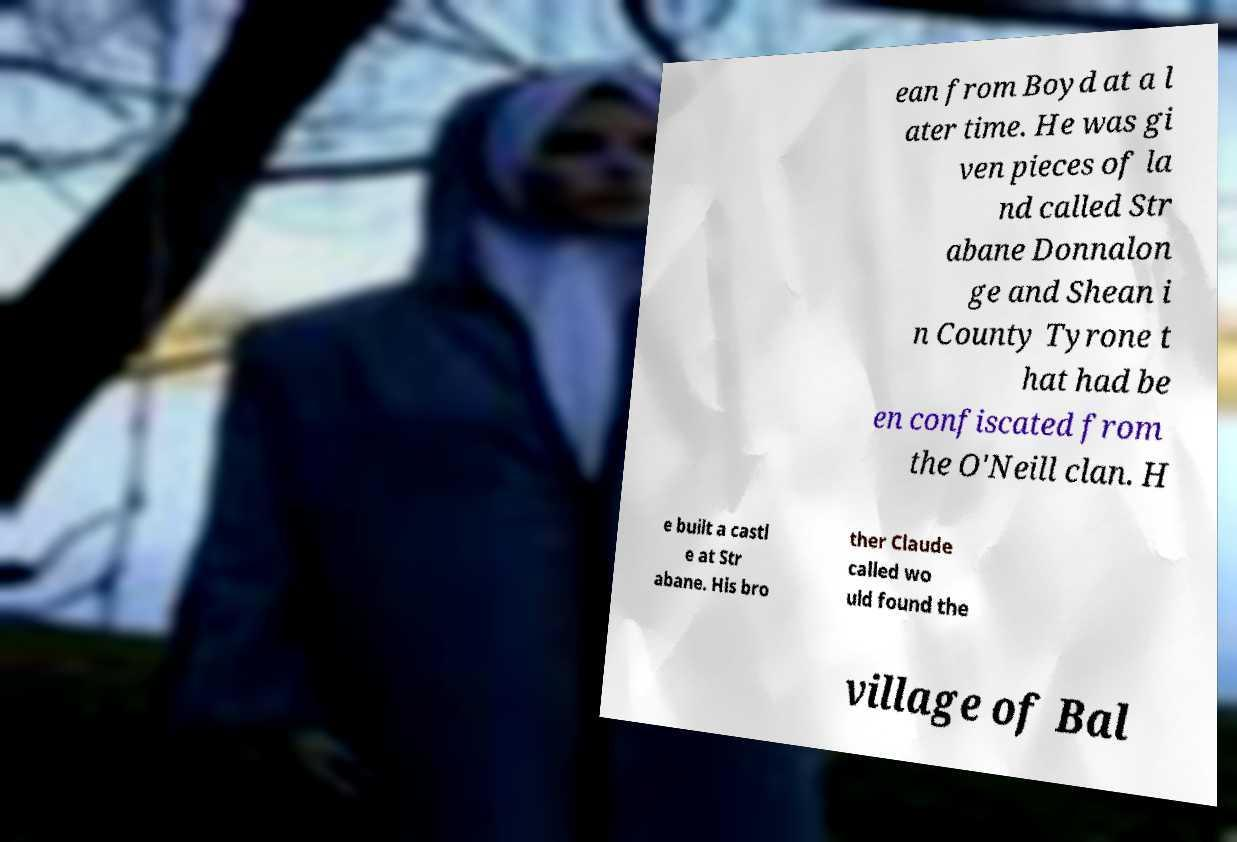There's text embedded in this image that I need extracted. Can you transcribe it verbatim? ean from Boyd at a l ater time. He was gi ven pieces of la nd called Str abane Donnalon ge and Shean i n County Tyrone t hat had be en confiscated from the O'Neill clan. H e built a castl e at Str abane. His bro ther Claude called wo uld found the village of Bal 